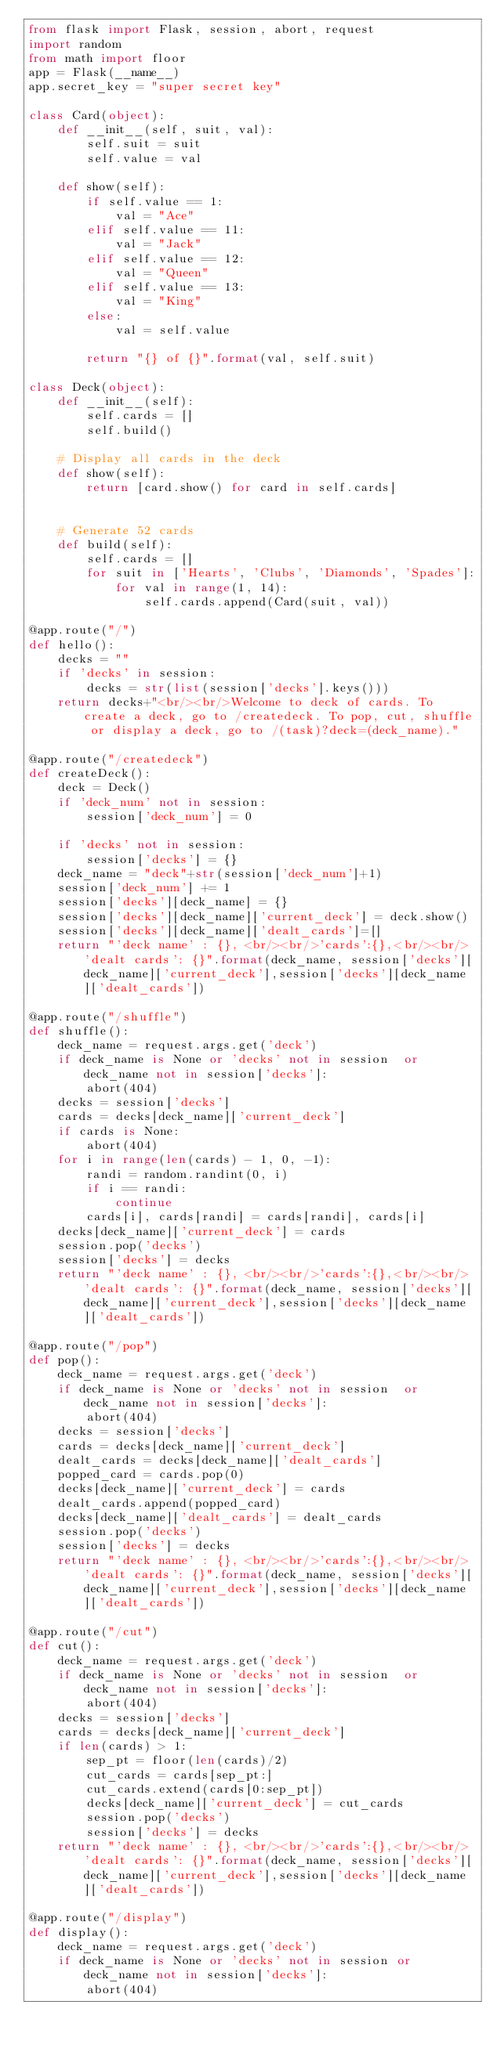Convert code to text. <code><loc_0><loc_0><loc_500><loc_500><_Python_>from flask import Flask, session, abort, request
import random
from math import floor
app = Flask(__name__)
app.secret_key = "super secret key"

class Card(object):
    def __init__(self, suit, val):
        self.suit = suit
        self.value = val

    def show(self):
        if self.value == 1:
            val = "Ace"
        elif self.value == 11:
            val = "Jack"
        elif self.value == 12:
            val = "Queen"
        elif self.value == 13:
            val = "King"
        else:
            val = self.value

        return "{} of {}".format(val, self.suit)

class Deck(object):
    def __init__(self):
        self.cards = []
        self.build()

    # Display all cards in the deck
    def show(self):
        return [card.show() for card in self.cards]


    # Generate 52 cards
    def build(self):
        self.cards = []
        for suit in ['Hearts', 'Clubs', 'Diamonds', 'Spades']:
            for val in range(1, 14):
                self.cards.append(Card(suit, val))

@app.route("/")
def hello():
    decks = ""
    if 'decks' in session:
        decks = str(list(session['decks'].keys()))
    return decks+"<br/><br/>Welcome to deck of cards. To create a deck, go to /createdeck. To pop, cut, shuffle or display a deck, go to /(task)?deck=(deck_name)."

@app.route("/createdeck")
def createDeck():
    deck = Deck()
    if 'deck_num' not in session:
        session['deck_num'] = 0

    if 'decks' not in session:
        session['decks'] = {}
    deck_name = "deck"+str(session['deck_num']+1)
    session['deck_num'] += 1
    session['decks'][deck_name] = {}
    session['decks'][deck_name]['current_deck'] = deck.show()
    session['decks'][deck_name]['dealt_cards']=[]
    return "'deck name' : {}, <br/><br/>'cards':{},<br/><br/> 'dealt cards': {}".format(deck_name, session['decks'][deck_name]['current_deck'],session['decks'][deck_name]['dealt_cards'])

@app.route("/shuffle")
def shuffle():
    deck_name = request.args.get('deck')
    if deck_name is None or 'decks' not in session  or deck_name not in session['decks']:
        abort(404)
    decks = session['decks']
    cards = decks[deck_name]['current_deck']
    if cards is None:
        abort(404)
    for i in range(len(cards) - 1, 0, -1):
        randi = random.randint(0, i)
        if i == randi:
            continue
        cards[i], cards[randi] = cards[randi], cards[i]
    decks[deck_name]['current_deck'] = cards
    session.pop('decks')
    session['decks'] = decks
    return "'deck name' : {}, <br/><br/>'cards':{},<br/><br/> 'dealt cards': {}".format(deck_name, session['decks'][deck_name]['current_deck'],session['decks'][deck_name]['dealt_cards'])

@app.route("/pop")
def pop():
    deck_name = request.args.get('deck')
    if deck_name is None or 'decks' not in session  or deck_name not in session['decks']:
        abort(404)
    decks = session['decks']
    cards = decks[deck_name]['current_deck']
    dealt_cards = decks[deck_name]['dealt_cards']
    popped_card = cards.pop(0)
    decks[deck_name]['current_deck'] = cards
    dealt_cards.append(popped_card)
    decks[deck_name]['dealt_cards'] = dealt_cards
    session.pop('decks')
    session['decks'] = decks
    return "'deck name' : {}, <br/><br/>'cards':{},<br/><br/> 'dealt cards': {}".format(deck_name, session['decks'][deck_name]['current_deck'],session['decks'][deck_name]['dealt_cards'])

@app.route("/cut")
def cut():
    deck_name = request.args.get('deck')
    if deck_name is None or 'decks' not in session  or deck_name not in session['decks']:
        abort(404)
    decks = session['decks']
    cards = decks[deck_name]['current_deck']
    if len(cards) > 1:
        sep_pt = floor(len(cards)/2)
        cut_cards = cards[sep_pt:]
        cut_cards.extend(cards[0:sep_pt])
        decks[deck_name]['current_deck'] = cut_cards
        session.pop('decks')
        session['decks'] = decks
    return "'deck name' : {}, <br/><br/>'cards':{},<br/><br/> 'dealt cards': {}".format(deck_name, session['decks'][deck_name]['current_deck'],session['decks'][deck_name]['dealt_cards'])

@app.route("/display")
def display():
    deck_name = request.args.get('deck')
    if deck_name is None or 'decks' not in session or deck_name not in session['decks']:
        abort(404)</code> 